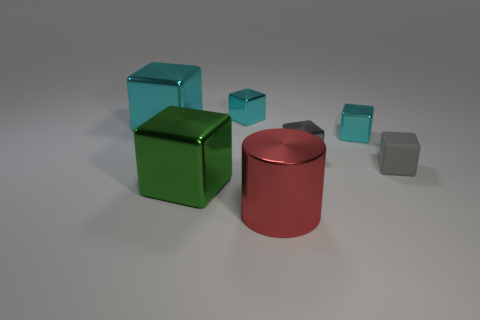Is the material of the big thing behind the green metal thing the same as the small gray object that is in front of the small gray metallic block?
Offer a terse response. No. There is a metal thing that is the same color as the matte object; what is its size?
Offer a very short reply. Small. What is the material of the small gray cube that is in front of the gray metal block?
Ensure brevity in your answer.  Rubber. Does the big shiny object to the left of the big green metallic object have the same shape as the cyan metal thing that is in front of the large cyan object?
Your answer should be very brief. Yes. What material is the other thing that is the same color as the tiny rubber thing?
Provide a short and direct response. Metal. Are any small cyan shiny blocks visible?
Make the answer very short. Yes. There is another gray object that is the same shape as the gray metal object; what is it made of?
Offer a terse response. Rubber. There is a large cyan thing; are there any small gray matte things on the right side of it?
Keep it short and to the point. Yes. Does the cube in front of the tiny matte thing have the same material as the red thing?
Your response must be concise. Yes. Are there any metallic objects of the same color as the rubber thing?
Ensure brevity in your answer.  Yes. 